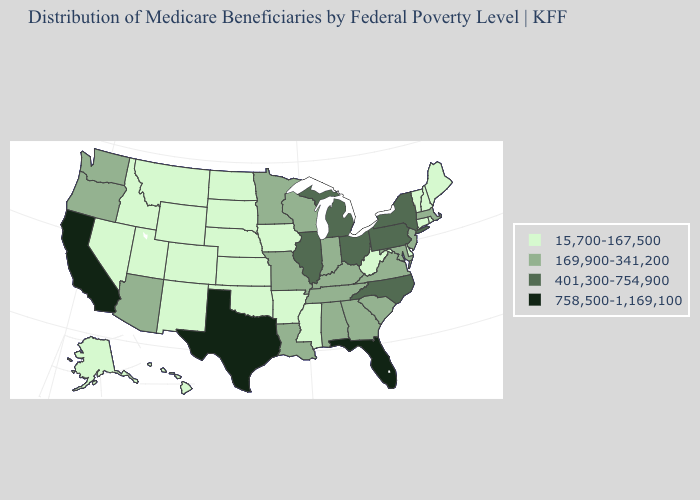Name the states that have a value in the range 169,900-341,200?
Write a very short answer. Alabama, Arizona, Georgia, Indiana, Kentucky, Louisiana, Maryland, Massachusetts, Minnesota, Missouri, New Jersey, Oregon, South Carolina, Tennessee, Virginia, Washington, Wisconsin. Name the states that have a value in the range 758,500-1,169,100?
Keep it brief. California, Florida, Texas. What is the value of Missouri?
Keep it brief. 169,900-341,200. Does California have the lowest value in the West?
Short answer required. No. Does the map have missing data?
Short answer required. No. Which states hav the highest value in the West?
Keep it brief. California. Is the legend a continuous bar?
Be succinct. No. What is the highest value in the USA?
Be succinct. 758,500-1,169,100. What is the value of Arizona?
Quick response, please. 169,900-341,200. What is the highest value in states that border Mississippi?
Be succinct. 169,900-341,200. What is the lowest value in the South?
Short answer required. 15,700-167,500. Name the states that have a value in the range 401,300-754,900?
Answer briefly. Illinois, Michigan, New York, North Carolina, Ohio, Pennsylvania. Does Oregon have a higher value than Virginia?
Quick response, please. No. What is the value of Hawaii?
Give a very brief answer. 15,700-167,500. 